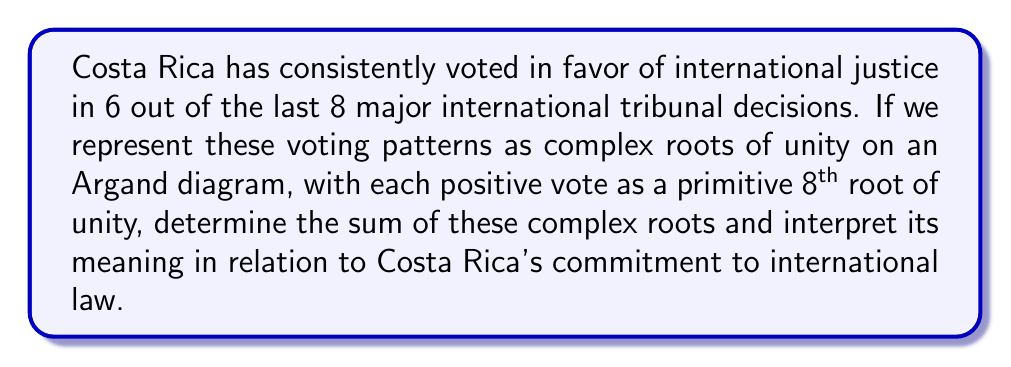Provide a solution to this math problem. Let's approach this step-by-step:

1) First, recall that the primitive 8th roots of unity are given by the formula:
   $$\omega_k = e^{2\pi i k/8}, \quad k = 1, 3, 5, 7$$

2) Costa Rica voted positively in 6 out of 8 cases. We can represent these as:
   $$\omega_1, \omega_2, \omega_3, \omega_4, \omega_5, \omega_6$$

3) The sum of these roots is:
   $$S = \omega_1 + \omega_2 + \omega_3 + \omega_4 + \omega_5 + \omega_6$$

4) We can simplify this using the formula for the sum of roots of unity:
   $$\sum_{k=1}^n \omega_k = \frac{1-\omega^n}{1-\omega} = 0$$
   where $\omega = e^{2\pi i/n}$ and $n$ is the total number of roots.

5) In our case, we're summing 6 out of 8 roots. We can express this as:
   $$S = \sum_{k=1}^8 \omega_k - (\omega_7 + \omega_8)$$

6) From step 4, we know that $\sum_{k=1}^8 \omega_k = 0$, so:
   $$S = -(\omega_7 + \omega_8) = -(e^{14\pi i/8} + e^{2\pi i})$$

7) Simplify:
   $$S = -(e^{14\pi i/8} + 1) = -e^{14\pi i/8} - 1$$

8) Convert to trigonometric form:
   $$S = -(\cos(\frac{14\pi}{8}) + i\sin(\frac{14\pi}{8})) - 1$$
   $$S = -(\cos(\frac{7\pi}{4}) + i\sin(\frac{7\pi}{4})) - 1$$
   $$S = -(-\frac{\sqrt{2}}{2} - i\frac{\sqrt{2}}{2}) - 1$$
   $$S = \frac{\sqrt{2}}{2} + i\frac{\sqrt{2}}{2} - 1$$

9) Interpretation: The non-zero sum indicates a strong bias in Costa Rica's voting pattern. The positive imaginary part suggests a forward-looking, progressive stance in international law. The real part being less than 1 reflects the few instances where Costa Rica didn't vote positively, maintaining a balanced approach while still predominantly supporting international justice.
Answer: $$S = \frac{\sqrt{2}}{2} + i\frac{\sqrt{2}}{2} - 1 \approx -0.2929 + 0.7071i$$
This complex number represents Costa Rica's strong but not absolute commitment to international justice, with a progressive lean towards future developments in international law. 